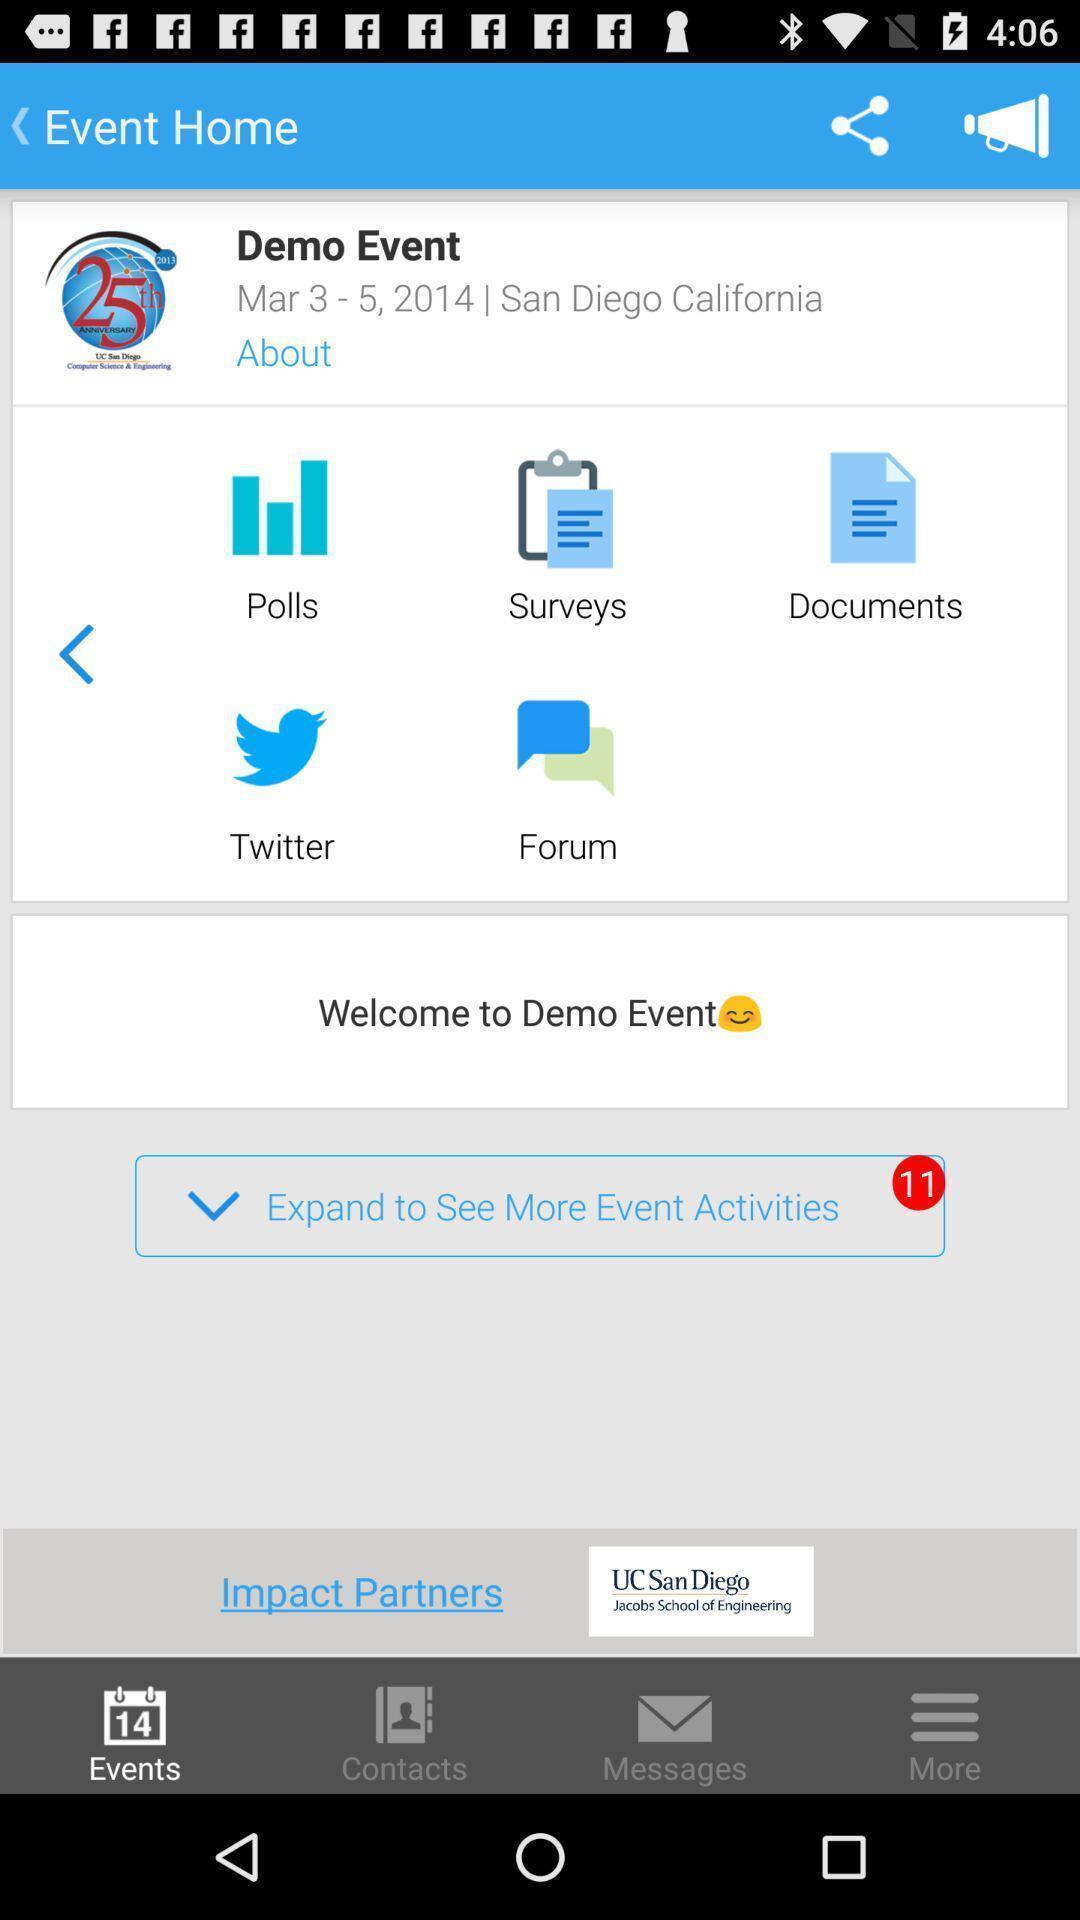Give me a summary of this screen capture. Window displaying a event page. 